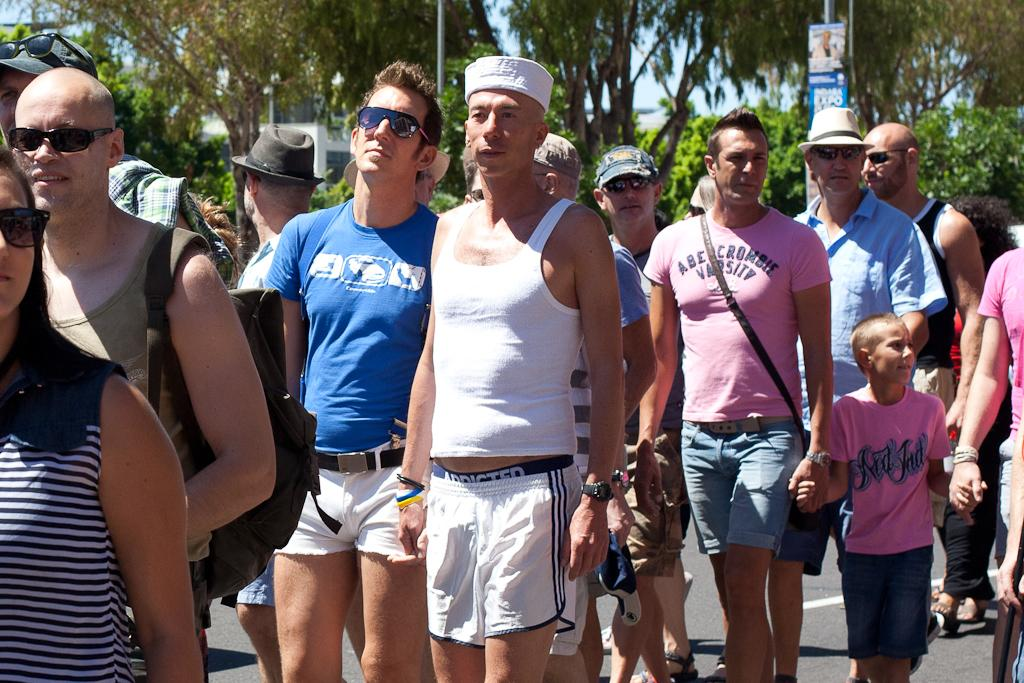<image>
Present a compact description of the photo's key features. A crowd of men, one with an Abercrombie Varsity shirt. 